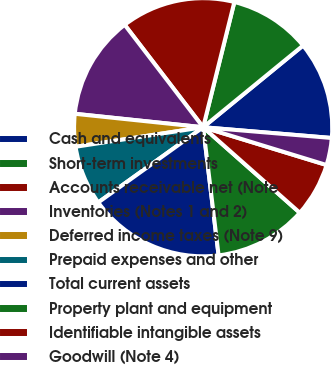Convert chart. <chart><loc_0><loc_0><loc_500><loc_500><pie_chart><fcel>Cash and equivalents<fcel>Short-term investments<fcel>Accounts receivable net (Note<fcel>Inventories (Notes 1 and 2)<fcel>Deferred income taxes (Note 9)<fcel>Prepaid expenses and other<fcel>Total current assets<fcel>Property plant and equipment<fcel>Identifiable intangible assets<fcel>Goodwill (Note 4)<nl><fcel>12.24%<fcel>10.2%<fcel>14.29%<fcel>12.93%<fcel>4.08%<fcel>7.48%<fcel>17.01%<fcel>11.56%<fcel>6.8%<fcel>3.4%<nl></chart> 